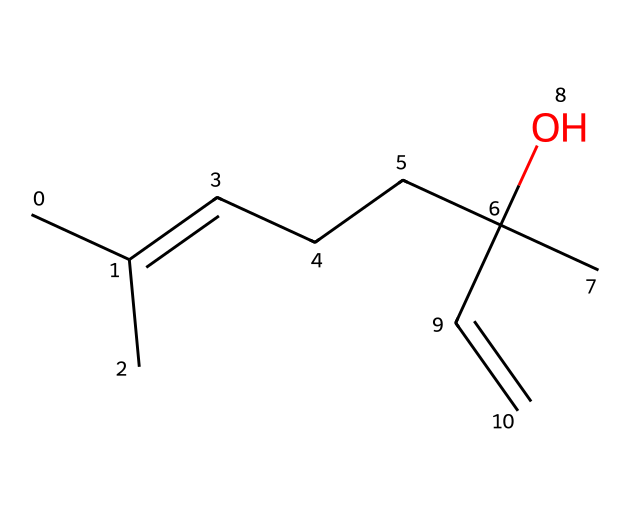How many carbon atoms are in linalool? The SMILES representation shows 10 carbon (C) symbols in it, indicating the total number of carbon atoms in the linalool molecule.
Answer: 10 What type of functional group is present in linalool? The presence of the alcohol (–OH) group in the structure (indicated by the presence of the "O" and the bond to a carbon atom) identifies linalool as containing an alcohol functional group.
Answer: alcohol How many double bonds does linalool contain? By examining the structure derived from the SMILES, there are two double bonds present, as indicated by the C=C notations in the chemical representation.
Answer: 2 What is the molecular formula of linalool? Upon counting the elements represented in the SMILES, the composition is determined to be C10H18O, indicating 10 carbons, 18 hydrogens, and 1 oxygen, which forms the molecular formula of linalool.
Answer: C10H18O Is linalool a terpene? Linalool's structure falls under the classification of terpenes, as it is a naturally occurring compound derived from plant sources and specifically belongs to the subclass of monoterpenes.
Answer: yes What characteristic aroma is associated with linalool? Linalool is known for its floral aroma, often described as having a lavender scent, which can be recognized in certain aromatic white wines due to its presence.
Answer: floral 